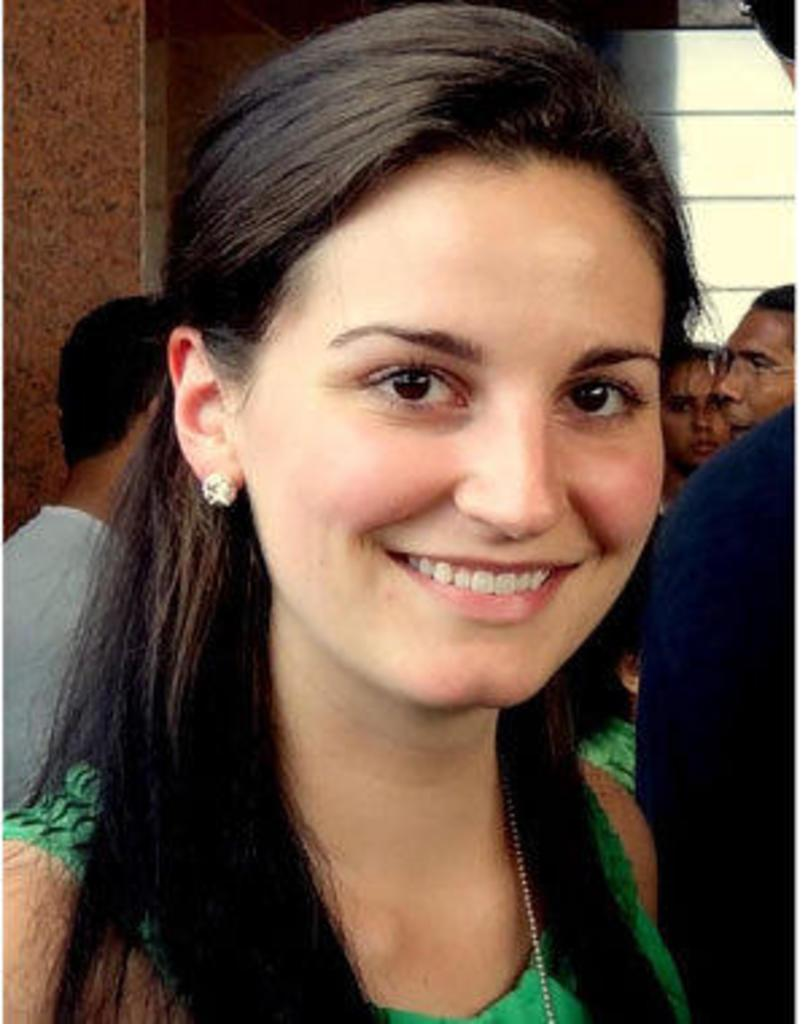Who is the main subject in the image? There is a woman in the image. What is the woman wearing? The woman is wearing a green dress. What is the woman's facial expression? The woman is smiling. Are there any other people visible in the image? Yes, there are other persons behind the woman. What type of net is being used by the woman in the image? There is no net present in the image. What historical event is being commemorated in the image? The image does not depict any specific historical event. 